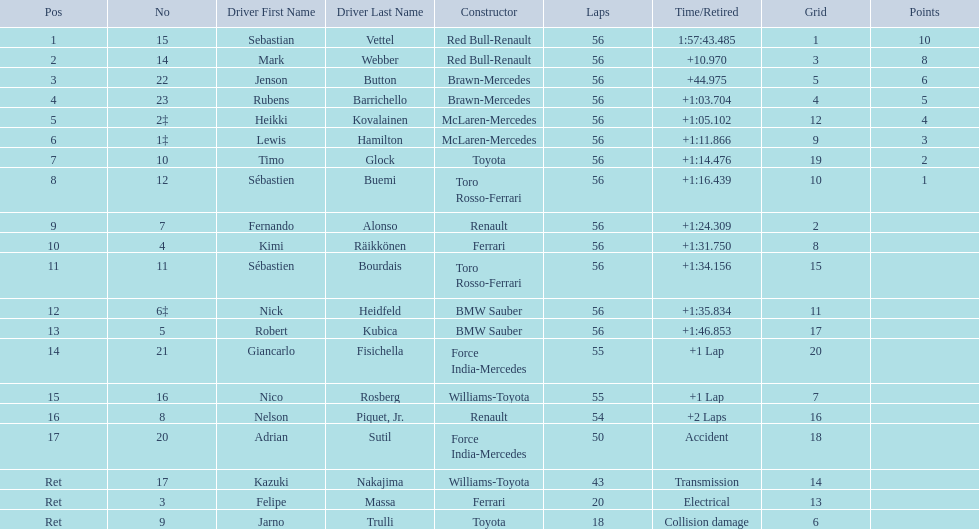Why did the  toyota retire Collision damage. Can you give me this table as a dict? {'header': ['Pos', 'No', 'Driver First Name', 'Driver Last Name', 'Constructor', 'Laps', 'Time/Retired', 'Grid', 'Points'], 'rows': [['1', '15', 'Sebastian', 'Vettel', 'Red Bull-Renault', '56', '1:57:43.485', '1', '10'], ['2', '14', 'Mark', 'Webber', 'Red Bull-Renault', '56', '+10.970', '3', '8'], ['3', '22', 'Jenson', 'Button', 'Brawn-Mercedes', '56', '+44.975', '5', '6'], ['4', '23', 'Rubens', 'Barrichello', 'Brawn-Mercedes', '56', '+1:03.704', '4', '5'], ['5', '2‡', 'Heikki', 'Kovalainen', 'McLaren-Mercedes', '56', '+1:05.102', '12', '4'], ['6', '1‡', 'Lewis', 'Hamilton', 'McLaren-Mercedes', '56', '+1:11.866', '9', '3'], ['7', '10', 'Timo', 'Glock', 'Toyota', '56', '+1:14.476', '19', '2'], ['8', '12', 'Sébastien', 'Buemi', 'Toro Rosso-Ferrari', '56', '+1:16.439', '10', '1'], ['9', '7', 'Fernando', 'Alonso', 'Renault', '56', '+1:24.309', '2', ''], ['10', '4', 'Kimi', 'Räikkönen', 'Ferrari', '56', '+1:31.750', '8', ''], ['11', '11', 'Sébastien', 'Bourdais', 'Toro Rosso-Ferrari', '56', '+1:34.156', '15', ''], ['12', '6‡', 'Nick', 'Heidfeld', 'BMW Sauber', '56', '+1:35.834', '11', ''], ['13', '5', 'Robert', 'Kubica', 'BMW Sauber', '56', '+1:46.853', '17', ''], ['14', '21', 'Giancarlo', 'Fisichella', 'Force India-Mercedes', '55', '+1 Lap', '20', ''], ['15', '16', 'Nico', 'Rosberg', 'Williams-Toyota', '55', '+1 Lap', '7', ''], ['16', '8', 'Nelson', 'Piquet, Jr.', 'Renault', '54', '+2 Laps', '16', ''], ['17', '20', 'Adrian', 'Sutil', 'Force India-Mercedes', '50', 'Accident', '18', ''], ['Ret', '17', 'Kazuki', 'Nakajima', 'Williams-Toyota', '43', 'Transmission', '14', ''], ['Ret', '3', 'Felipe', 'Massa', 'Ferrari', '20', 'Electrical', '13', ''], ['Ret', '9', 'Jarno', 'Trulli', 'Toyota', '18', 'Collision damage', '6', '']]} What was the drivers name? Jarno Trulli. 